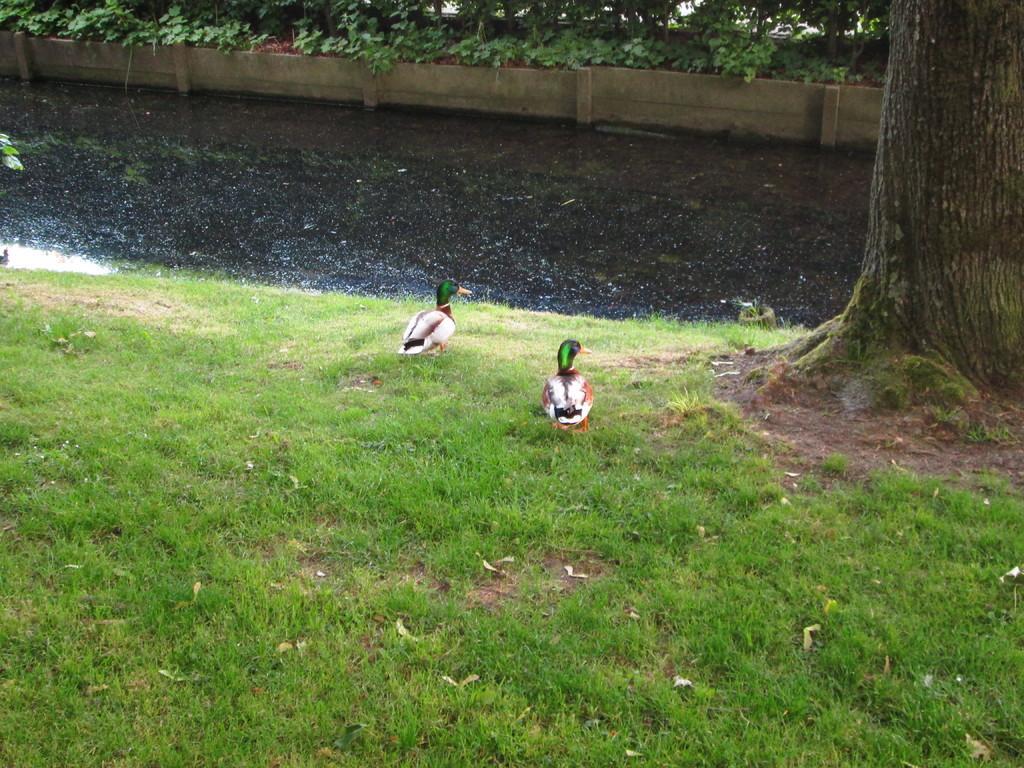Could you give a brief overview of what you see in this image? This is an outside view. At the bottom, I can see the grass on the ground and there are two birds. On the right side there is a tree trunk. At the top of the image there is a river and at the top there are few plants. 